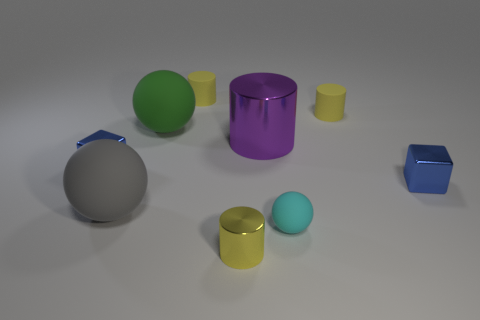How many yellow cylinders must be subtracted to get 1 yellow cylinders? 2 Subtract all brown cubes. How many yellow cylinders are left? 3 Add 1 tiny yellow metallic cylinders. How many objects exist? 10 Subtract all cylinders. How many objects are left? 5 Subtract all gray spheres. Subtract all small metal things. How many objects are left? 5 Add 4 big purple metal objects. How many big purple metal objects are left? 5 Add 7 big red metal balls. How many big red metal balls exist? 7 Subtract 1 blue blocks. How many objects are left? 8 